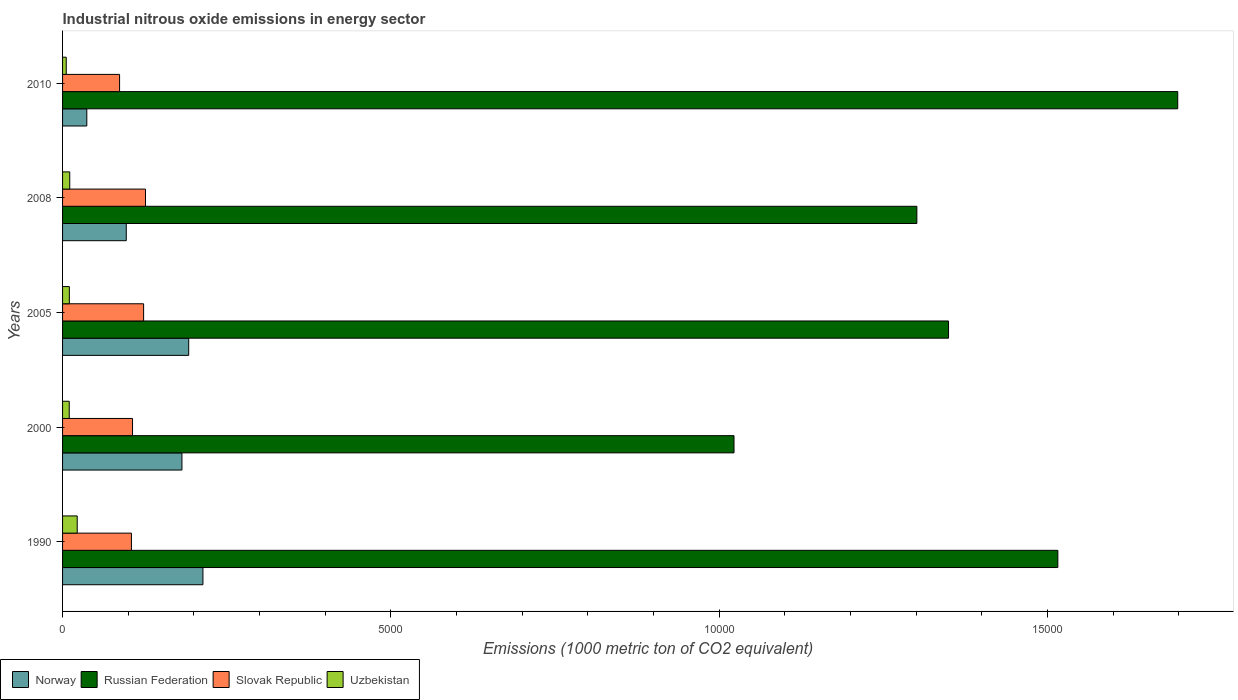How many different coloured bars are there?
Offer a very short reply. 4. How many groups of bars are there?
Provide a succinct answer. 5. Are the number of bars per tick equal to the number of legend labels?
Provide a succinct answer. Yes. Are the number of bars on each tick of the Y-axis equal?
Keep it short and to the point. Yes. What is the amount of industrial nitrous oxide emitted in Slovak Republic in 1990?
Give a very brief answer. 1049. Across all years, what is the maximum amount of industrial nitrous oxide emitted in Russian Federation?
Your answer should be very brief. 1.70e+04. Across all years, what is the minimum amount of industrial nitrous oxide emitted in Slovak Republic?
Your answer should be compact. 868.5. In which year was the amount of industrial nitrous oxide emitted in Uzbekistan maximum?
Your answer should be very brief. 1990. What is the total amount of industrial nitrous oxide emitted in Norway in the graph?
Provide a short and direct response. 7217.1. What is the difference between the amount of industrial nitrous oxide emitted in Norway in 1990 and that in 2010?
Your answer should be very brief. 1768.7. What is the difference between the amount of industrial nitrous oxide emitted in Russian Federation in 1990 and the amount of industrial nitrous oxide emitted in Norway in 2005?
Keep it short and to the point. 1.32e+04. What is the average amount of industrial nitrous oxide emitted in Norway per year?
Give a very brief answer. 1443.42. In the year 2005, what is the difference between the amount of industrial nitrous oxide emitted in Russian Federation and amount of industrial nitrous oxide emitted in Uzbekistan?
Your response must be concise. 1.34e+04. In how many years, is the amount of industrial nitrous oxide emitted in Russian Federation greater than 1000 1000 metric ton?
Offer a terse response. 5. What is the ratio of the amount of industrial nitrous oxide emitted in Uzbekistan in 2000 to that in 2008?
Offer a very short reply. 0.93. Is the amount of industrial nitrous oxide emitted in Norway in 1990 less than that in 2008?
Give a very brief answer. No. Is the difference between the amount of industrial nitrous oxide emitted in Russian Federation in 1990 and 2000 greater than the difference between the amount of industrial nitrous oxide emitted in Uzbekistan in 1990 and 2000?
Ensure brevity in your answer.  Yes. What is the difference between the highest and the second highest amount of industrial nitrous oxide emitted in Norway?
Offer a very short reply. 216.8. What is the difference between the highest and the lowest amount of industrial nitrous oxide emitted in Russian Federation?
Make the answer very short. 6758.6. In how many years, is the amount of industrial nitrous oxide emitted in Norway greater than the average amount of industrial nitrous oxide emitted in Norway taken over all years?
Keep it short and to the point. 3. What does the 4th bar from the bottom in 2008 represents?
Your response must be concise. Uzbekistan. How many bars are there?
Your answer should be compact. 20. What is the difference between two consecutive major ticks on the X-axis?
Keep it short and to the point. 5000. Are the values on the major ticks of X-axis written in scientific E-notation?
Your answer should be compact. No. Does the graph contain grids?
Your answer should be very brief. No. What is the title of the graph?
Give a very brief answer. Industrial nitrous oxide emissions in energy sector. What is the label or title of the X-axis?
Provide a succinct answer. Emissions (1000 metric ton of CO2 equivalent). What is the label or title of the Y-axis?
Offer a terse response. Years. What is the Emissions (1000 metric ton of CO2 equivalent) of Norway in 1990?
Provide a short and direct response. 2138. What is the Emissions (1000 metric ton of CO2 equivalent) of Russian Federation in 1990?
Keep it short and to the point. 1.52e+04. What is the Emissions (1000 metric ton of CO2 equivalent) of Slovak Republic in 1990?
Your answer should be very brief. 1049. What is the Emissions (1000 metric ton of CO2 equivalent) of Uzbekistan in 1990?
Your answer should be compact. 223.2. What is the Emissions (1000 metric ton of CO2 equivalent) of Norway in 2000?
Give a very brief answer. 1818.2. What is the Emissions (1000 metric ton of CO2 equivalent) of Russian Federation in 2000?
Your response must be concise. 1.02e+04. What is the Emissions (1000 metric ton of CO2 equivalent) of Slovak Republic in 2000?
Make the answer very short. 1065.7. What is the Emissions (1000 metric ton of CO2 equivalent) of Uzbekistan in 2000?
Ensure brevity in your answer.  101.6. What is the Emissions (1000 metric ton of CO2 equivalent) in Norway in 2005?
Provide a succinct answer. 1921.2. What is the Emissions (1000 metric ton of CO2 equivalent) of Russian Federation in 2005?
Provide a succinct answer. 1.35e+04. What is the Emissions (1000 metric ton of CO2 equivalent) in Slovak Republic in 2005?
Offer a very short reply. 1234.3. What is the Emissions (1000 metric ton of CO2 equivalent) in Uzbekistan in 2005?
Your answer should be very brief. 103.2. What is the Emissions (1000 metric ton of CO2 equivalent) of Norway in 2008?
Ensure brevity in your answer.  970.4. What is the Emissions (1000 metric ton of CO2 equivalent) in Russian Federation in 2008?
Provide a succinct answer. 1.30e+04. What is the Emissions (1000 metric ton of CO2 equivalent) of Slovak Republic in 2008?
Provide a succinct answer. 1263.1. What is the Emissions (1000 metric ton of CO2 equivalent) in Uzbekistan in 2008?
Offer a terse response. 109.4. What is the Emissions (1000 metric ton of CO2 equivalent) of Norway in 2010?
Your answer should be compact. 369.3. What is the Emissions (1000 metric ton of CO2 equivalent) of Russian Federation in 2010?
Make the answer very short. 1.70e+04. What is the Emissions (1000 metric ton of CO2 equivalent) of Slovak Republic in 2010?
Your response must be concise. 868.5. What is the Emissions (1000 metric ton of CO2 equivalent) of Uzbekistan in 2010?
Provide a short and direct response. 56.1. Across all years, what is the maximum Emissions (1000 metric ton of CO2 equivalent) of Norway?
Make the answer very short. 2138. Across all years, what is the maximum Emissions (1000 metric ton of CO2 equivalent) in Russian Federation?
Give a very brief answer. 1.70e+04. Across all years, what is the maximum Emissions (1000 metric ton of CO2 equivalent) in Slovak Republic?
Provide a succinct answer. 1263.1. Across all years, what is the maximum Emissions (1000 metric ton of CO2 equivalent) of Uzbekistan?
Your response must be concise. 223.2. Across all years, what is the minimum Emissions (1000 metric ton of CO2 equivalent) of Norway?
Make the answer very short. 369.3. Across all years, what is the minimum Emissions (1000 metric ton of CO2 equivalent) in Russian Federation?
Make the answer very short. 1.02e+04. Across all years, what is the minimum Emissions (1000 metric ton of CO2 equivalent) of Slovak Republic?
Your answer should be compact. 868.5. Across all years, what is the minimum Emissions (1000 metric ton of CO2 equivalent) in Uzbekistan?
Provide a succinct answer. 56.1. What is the total Emissions (1000 metric ton of CO2 equivalent) of Norway in the graph?
Ensure brevity in your answer.  7217.1. What is the total Emissions (1000 metric ton of CO2 equivalent) of Russian Federation in the graph?
Keep it short and to the point. 6.89e+04. What is the total Emissions (1000 metric ton of CO2 equivalent) in Slovak Republic in the graph?
Make the answer very short. 5480.6. What is the total Emissions (1000 metric ton of CO2 equivalent) in Uzbekistan in the graph?
Provide a succinct answer. 593.5. What is the difference between the Emissions (1000 metric ton of CO2 equivalent) in Norway in 1990 and that in 2000?
Provide a succinct answer. 319.8. What is the difference between the Emissions (1000 metric ton of CO2 equivalent) in Russian Federation in 1990 and that in 2000?
Ensure brevity in your answer.  4932.4. What is the difference between the Emissions (1000 metric ton of CO2 equivalent) of Slovak Republic in 1990 and that in 2000?
Keep it short and to the point. -16.7. What is the difference between the Emissions (1000 metric ton of CO2 equivalent) in Uzbekistan in 1990 and that in 2000?
Give a very brief answer. 121.6. What is the difference between the Emissions (1000 metric ton of CO2 equivalent) in Norway in 1990 and that in 2005?
Ensure brevity in your answer.  216.8. What is the difference between the Emissions (1000 metric ton of CO2 equivalent) in Russian Federation in 1990 and that in 2005?
Your answer should be very brief. 1664.9. What is the difference between the Emissions (1000 metric ton of CO2 equivalent) of Slovak Republic in 1990 and that in 2005?
Keep it short and to the point. -185.3. What is the difference between the Emissions (1000 metric ton of CO2 equivalent) of Uzbekistan in 1990 and that in 2005?
Offer a terse response. 120. What is the difference between the Emissions (1000 metric ton of CO2 equivalent) in Norway in 1990 and that in 2008?
Ensure brevity in your answer.  1167.6. What is the difference between the Emissions (1000 metric ton of CO2 equivalent) of Russian Federation in 1990 and that in 2008?
Ensure brevity in your answer.  2147.2. What is the difference between the Emissions (1000 metric ton of CO2 equivalent) of Slovak Republic in 1990 and that in 2008?
Your answer should be compact. -214.1. What is the difference between the Emissions (1000 metric ton of CO2 equivalent) of Uzbekistan in 1990 and that in 2008?
Make the answer very short. 113.8. What is the difference between the Emissions (1000 metric ton of CO2 equivalent) in Norway in 1990 and that in 2010?
Keep it short and to the point. 1768.7. What is the difference between the Emissions (1000 metric ton of CO2 equivalent) of Russian Federation in 1990 and that in 2010?
Your answer should be compact. -1826.2. What is the difference between the Emissions (1000 metric ton of CO2 equivalent) in Slovak Republic in 1990 and that in 2010?
Ensure brevity in your answer.  180.5. What is the difference between the Emissions (1000 metric ton of CO2 equivalent) in Uzbekistan in 1990 and that in 2010?
Your answer should be very brief. 167.1. What is the difference between the Emissions (1000 metric ton of CO2 equivalent) in Norway in 2000 and that in 2005?
Your response must be concise. -103. What is the difference between the Emissions (1000 metric ton of CO2 equivalent) in Russian Federation in 2000 and that in 2005?
Offer a very short reply. -3267.5. What is the difference between the Emissions (1000 metric ton of CO2 equivalent) in Slovak Republic in 2000 and that in 2005?
Make the answer very short. -168.6. What is the difference between the Emissions (1000 metric ton of CO2 equivalent) in Uzbekistan in 2000 and that in 2005?
Provide a short and direct response. -1.6. What is the difference between the Emissions (1000 metric ton of CO2 equivalent) in Norway in 2000 and that in 2008?
Your answer should be compact. 847.8. What is the difference between the Emissions (1000 metric ton of CO2 equivalent) of Russian Federation in 2000 and that in 2008?
Ensure brevity in your answer.  -2785.2. What is the difference between the Emissions (1000 metric ton of CO2 equivalent) of Slovak Republic in 2000 and that in 2008?
Make the answer very short. -197.4. What is the difference between the Emissions (1000 metric ton of CO2 equivalent) in Uzbekistan in 2000 and that in 2008?
Keep it short and to the point. -7.8. What is the difference between the Emissions (1000 metric ton of CO2 equivalent) in Norway in 2000 and that in 2010?
Ensure brevity in your answer.  1448.9. What is the difference between the Emissions (1000 metric ton of CO2 equivalent) in Russian Federation in 2000 and that in 2010?
Ensure brevity in your answer.  -6758.6. What is the difference between the Emissions (1000 metric ton of CO2 equivalent) in Slovak Republic in 2000 and that in 2010?
Offer a terse response. 197.2. What is the difference between the Emissions (1000 metric ton of CO2 equivalent) in Uzbekistan in 2000 and that in 2010?
Make the answer very short. 45.5. What is the difference between the Emissions (1000 metric ton of CO2 equivalent) in Norway in 2005 and that in 2008?
Provide a succinct answer. 950.8. What is the difference between the Emissions (1000 metric ton of CO2 equivalent) in Russian Federation in 2005 and that in 2008?
Make the answer very short. 482.3. What is the difference between the Emissions (1000 metric ton of CO2 equivalent) in Slovak Republic in 2005 and that in 2008?
Give a very brief answer. -28.8. What is the difference between the Emissions (1000 metric ton of CO2 equivalent) of Norway in 2005 and that in 2010?
Keep it short and to the point. 1551.9. What is the difference between the Emissions (1000 metric ton of CO2 equivalent) in Russian Federation in 2005 and that in 2010?
Provide a short and direct response. -3491.1. What is the difference between the Emissions (1000 metric ton of CO2 equivalent) in Slovak Republic in 2005 and that in 2010?
Offer a very short reply. 365.8. What is the difference between the Emissions (1000 metric ton of CO2 equivalent) of Uzbekistan in 2005 and that in 2010?
Give a very brief answer. 47.1. What is the difference between the Emissions (1000 metric ton of CO2 equivalent) in Norway in 2008 and that in 2010?
Offer a terse response. 601.1. What is the difference between the Emissions (1000 metric ton of CO2 equivalent) in Russian Federation in 2008 and that in 2010?
Give a very brief answer. -3973.4. What is the difference between the Emissions (1000 metric ton of CO2 equivalent) of Slovak Republic in 2008 and that in 2010?
Your answer should be compact. 394.6. What is the difference between the Emissions (1000 metric ton of CO2 equivalent) of Uzbekistan in 2008 and that in 2010?
Your answer should be very brief. 53.3. What is the difference between the Emissions (1000 metric ton of CO2 equivalent) of Norway in 1990 and the Emissions (1000 metric ton of CO2 equivalent) of Russian Federation in 2000?
Provide a short and direct response. -8089.1. What is the difference between the Emissions (1000 metric ton of CO2 equivalent) in Norway in 1990 and the Emissions (1000 metric ton of CO2 equivalent) in Slovak Republic in 2000?
Give a very brief answer. 1072.3. What is the difference between the Emissions (1000 metric ton of CO2 equivalent) in Norway in 1990 and the Emissions (1000 metric ton of CO2 equivalent) in Uzbekistan in 2000?
Give a very brief answer. 2036.4. What is the difference between the Emissions (1000 metric ton of CO2 equivalent) of Russian Federation in 1990 and the Emissions (1000 metric ton of CO2 equivalent) of Slovak Republic in 2000?
Your response must be concise. 1.41e+04. What is the difference between the Emissions (1000 metric ton of CO2 equivalent) of Russian Federation in 1990 and the Emissions (1000 metric ton of CO2 equivalent) of Uzbekistan in 2000?
Your response must be concise. 1.51e+04. What is the difference between the Emissions (1000 metric ton of CO2 equivalent) of Slovak Republic in 1990 and the Emissions (1000 metric ton of CO2 equivalent) of Uzbekistan in 2000?
Provide a short and direct response. 947.4. What is the difference between the Emissions (1000 metric ton of CO2 equivalent) in Norway in 1990 and the Emissions (1000 metric ton of CO2 equivalent) in Russian Federation in 2005?
Give a very brief answer. -1.14e+04. What is the difference between the Emissions (1000 metric ton of CO2 equivalent) in Norway in 1990 and the Emissions (1000 metric ton of CO2 equivalent) in Slovak Republic in 2005?
Offer a very short reply. 903.7. What is the difference between the Emissions (1000 metric ton of CO2 equivalent) in Norway in 1990 and the Emissions (1000 metric ton of CO2 equivalent) in Uzbekistan in 2005?
Give a very brief answer. 2034.8. What is the difference between the Emissions (1000 metric ton of CO2 equivalent) in Russian Federation in 1990 and the Emissions (1000 metric ton of CO2 equivalent) in Slovak Republic in 2005?
Your answer should be very brief. 1.39e+04. What is the difference between the Emissions (1000 metric ton of CO2 equivalent) in Russian Federation in 1990 and the Emissions (1000 metric ton of CO2 equivalent) in Uzbekistan in 2005?
Ensure brevity in your answer.  1.51e+04. What is the difference between the Emissions (1000 metric ton of CO2 equivalent) in Slovak Republic in 1990 and the Emissions (1000 metric ton of CO2 equivalent) in Uzbekistan in 2005?
Provide a short and direct response. 945.8. What is the difference between the Emissions (1000 metric ton of CO2 equivalent) of Norway in 1990 and the Emissions (1000 metric ton of CO2 equivalent) of Russian Federation in 2008?
Offer a terse response. -1.09e+04. What is the difference between the Emissions (1000 metric ton of CO2 equivalent) in Norway in 1990 and the Emissions (1000 metric ton of CO2 equivalent) in Slovak Republic in 2008?
Your answer should be compact. 874.9. What is the difference between the Emissions (1000 metric ton of CO2 equivalent) of Norway in 1990 and the Emissions (1000 metric ton of CO2 equivalent) of Uzbekistan in 2008?
Your answer should be compact. 2028.6. What is the difference between the Emissions (1000 metric ton of CO2 equivalent) of Russian Federation in 1990 and the Emissions (1000 metric ton of CO2 equivalent) of Slovak Republic in 2008?
Provide a succinct answer. 1.39e+04. What is the difference between the Emissions (1000 metric ton of CO2 equivalent) of Russian Federation in 1990 and the Emissions (1000 metric ton of CO2 equivalent) of Uzbekistan in 2008?
Ensure brevity in your answer.  1.51e+04. What is the difference between the Emissions (1000 metric ton of CO2 equivalent) in Slovak Republic in 1990 and the Emissions (1000 metric ton of CO2 equivalent) in Uzbekistan in 2008?
Your answer should be compact. 939.6. What is the difference between the Emissions (1000 metric ton of CO2 equivalent) in Norway in 1990 and the Emissions (1000 metric ton of CO2 equivalent) in Russian Federation in 2010?
Offer a terse response. -1.48e+04. What is the difference between the Emissions (1000 metric ton of CO2 equivalent) of Norway in 1990 and the Emissions (1000 metric ton of CO2 equivalent) of Slovak Republic in 2010?
Make the answer very short. 1269.5. What is the difference between the Emissions (1000 metric ton of CO2 equivalent) in Norway in 1990 and the Emissions (1000 metric ton of CO2 equivalent) in Uzbekistan in 2010?
Provide a succinct answer. 2081.9. What is the difference between the Emissions (1000 metric ton of CO2 equivalent) of Russian Federation in 1990 and the Emissions (1000 metric ton of CO2 equivalent) of Slovak Republic in 2010?
Your answer should be compact. 1.43e+04. What is the difference between the Emissions (1000 metric ton of CO2 equivalent) in Russian Federation in 1990 and the Emissions (1000 metric ton of CO2 equivalent) in Uzbekistan in 2010?
Offer a very short reply. 1.51e+04. What is the difference between the Emissions (1000 metric ton of CO2 equivalent) of Slovak Republic in 1990 and the Emissions (1000 metric ton of CO2 equivalent) of Uzbekistan in 2010?
Your response must be concise. 992.9. What is the difference between the Emissions (1000 metric ton of CO2 equivalent) in Norway in 2000 and the Emissions (1000 metric ton of CO2 equivalent) in Russian Federation in 2005?
Ensure brevity in your answer.  -1.17e+04. What is the difference between the Emissions (1000 metric ton of CO2 equivalent) in Norway in 2000 and the Emissions (1000 metric ton of CO2 equivalent) in Slovak Republic in 2005?
Make the answer very short. 583.9. What is the difference between the Emissions (1000 metric ton of CO2 equivalent) in Norway in 2000 and the Emissions (1000 metric ton of CO2 equivalent) in Uzbekistan in 2005?
Offer a very short reply. 1715. What is the difference between the Emissions (1000 metric ton of CO2 equivalent) of Russian Federation in 2000 and the Emissions (1000 metric ton of CO2 equivalent) of Slovak Republic in 2005?
Ensure brevity in your answer.  8992.8. What is the difference between the Emissions (1000 metric ton of CO2 equivalent) in Russian Federation in 2000 and the Emissions (1000 metric ton of CO2 equivalent) in Uzbekistan in 2005?
Ensure brevity in your answer.  1.01e+04. What is the difference between the Emissions (1000 metric ton of CO2 equivalent) in Slovak Republic in 2000 and the Emissions (1000 metric ton of CO2 equivalent) in Uzbekistan in 2005?
Keep it short and to the point. 962.5. What is the difference between the Emissions (1000 metric ton of CO2 equivalent) of Norway in 2000 and the Emissions (1000 metric ton of CO2 equivalent) of Russian Federation in 2008?
Give a very brief answer. -1.12e+04. What is the difference between the Emissions (1000 metric ton of CO2 equivalent) of Norway in 2000 and the Emissions (1000 metric ton of CO2 equivalent) of Slovak Republic in 2008?
Make the answer very short. 555.1. What is the difference between the Emissions (1000 metric ton of CO2 equivalent) of Norway in 2000 and the Emissions (1000 metric ton of CO2 equivalent) of Uzbekistan in 2008?
Offer a very short reply. 1708.8. What is the difference between the Emissions (1000 metric ton of CO2 equivalent) of Russian Federation in 2000 and the Emissions (1000 metric ton of CO2 equivalent) of Slovak Republic in 2008?
Offer a very short reply. 8964. What is the difference between the Emissions (1000 metric ton of CO2 equivalent) of Russian Federation in 2000 and the Emissions (1000 metric ton of CO2 equivalent) of Uzbekistan in 2008?
Provide a short and direct response. 1.01e+04. What is the difference between the Emissions (1000 metric ton of CO2 equivalent) of Slovak Republic in 2000 and the Emissions (1000 metric ton of CO2 equivalent) of Uzbekistan in 2008?
Your answer should be very brief. 956.3. What is the difference between the Emissions (1000 metric ton of CO2 equivalent) of Norway in 2000 and the Emissions (1000 metric ton of CO2 equivalent) of Russian Federation in 2010?
Keep it short and to the point. -1.52e+04. What is the difference between the Emissions (1000 metric ton of CO2 equivalent) of Norway in 2000 and the Emissions (1000 metric ton of CO2 equivalent) of Slovak Republic in 2010?
Offer a very short reply. 949.7. What is the difference between the Emissions (1000 metric ton of CO2 equivalent) in Norway in 2000 and the Emissions (1000 metric ton of CO2 equivalent) in Uzbekistan in 2010?
Keep it short and to the point. 1762.1. What is the difference between the Emissions (1000 metric ton of CO2 equivalent) in Russian Federation in 2000 and the Emissions (1000 metric ton of CO2 equivalent) in Slovak Republic in 2010?
Your answer should be very brief. 9358.6. What is the difference between the Emissions (1000 metric ton of CO2 equivalent) in Russian Federation in 2000 and the Emissions (1000 metric ton of CO2 equivalent) in Uzbekistan in 2010?
Offer a terse response. 1.02e+04. What is the difference between the Emissions (1000 metric ton of CO2 equivalent) in Slovak Republic in 2000 and the Emissions (1000 metric ton of CO2 equivalent) in Uzbekistan in 2010?
Give a very brief answer. 1009.6. What is the difference between the Emissions (1000 metric ton of CO2 equivalent) in Norway in 2005 and the Emissions (1000 metric ton of CO2 equivalent) in Russian Federation in 2008?
Your answer should be very brief. -1.11e+04. What is the difference between the Emissions (1000 metric ton of CO2 equivalent) of Norway in 2005 and the Emissions (1000 metric ton of CO2 equivalent) of Slovak Republic in 2008?
Provide a succinct answer. 658.1. What is the difference between the Emissions (1000 metric ton of CO2 equivalent) of Norway in 2005 and the Emissions (1000 metric ton of CO2 equivalent) of Uzbekistan in 2008?
Your answer should be very brief. 1811.8. What is the difference between the Emissions (1000 metric ton of CO2 equivalent) of Russian Federation in 2005 and the Emissions (1000 metric ton of CO2 equivalent) of Slovak Republic in 2008?
Keep it short and to the point. 1.22e+04. What is the difference between the Emissions (1000 metric ton of CO2 equivalent) in Russian Federation in 2005 and the Emissions (1000 metric ton of CO2 equivalent) in Uzbekistan in 2008?
Your answer should be very brief. 1.34e+04. What is the difference between the Emissions (1000 metric ton of CO2 equivalent) of Slovak Republic in 2005 and the Emissions (1000 metric ton of CO2 equivalent) of Uzbekistan in 2008?
Make the answer very short. 1124.9. What is the difference between the Emissions (1000 metric ton of CO2 equivalent) in Norway in 2005 and the Emissions (1000 metric ton of CO2 equivalent) in Russian Federation in 2010?
Your answer should be very brief. -1.51e+04. What is the difference between the Emissions (1000 metric ton of CO2 equivalent) of Norway in 2005 and the Emissions (1000 metric ton of CO2 equivalent) of Slovak Republic in 2010?
Offer a very short reply. 1052.7. What is the difference between the Emissions (1000 metric ton of CO2 equivalent) in Norway in 2005 and the Emissions (1000 metric ton of CO2 equivalent) in Uzbekistan in 2010?
Provide a succinct answer. 1865.1. What is the difference between the Emissions (1000 metric ton of CO2 equivalent) of Russian Federation in 2005 and the Emissions (1000 metric ton of CO2 equivalent) of Slovak Republic in 2010?
Ensure brevity in your answer.  1.26e+04. What is the difference between the Emissions (1000 metric ton of CO2 equivalent) of Russian Federation in 2005 and the Emissions (1000 metric ton of CO2 equivalent) of Uzbekistan in 2010?
Offer a very short reply. 1.34e+04. What is the difference between the Emissions (1000 metric ton of CO2 equivalent) of Slovak Republic in 2005 and the Emissions (1000 metric ton of CO2 equivalent) of Uzbekistan in 2010?
Keep it short and to the point. 1178.2. What is the difference between the Emissions (1000 metric ton of CO2 equivalent) of Norway in 2008 and the Emissions (1000 metric ton of CO2 equivalent) of Russian Federation in 2010?
Offer a very short reply. -1.60e+04. What is the difference between the Emissions (1000 metric ton of CO2 equivalent) of Norway in 2008 and the Emissions (1000 metric ton of CO2 equivalent) of Slovak Republic in 2010?
Give a very brief answer. 101.9. What is the difference between the Emissions (1000 metric ton of CO2 equivalent) of Norway in 2008 and the Emissions (1000 metric ton of CO2 equivalent) of Uzbekistan in 2010?
Give a very brief answer. 914.3. What is the difference between the Emissions (1000 metric ton of CO2 equivalent) in Russian Federation in 2008 and the Emissions (1000 metric ton of CO2 equivalent) in Slovak Republic in 2010?
Ensure brevity in your answer.  1.21e+04. What is the difference between the Emissions (1000 metric ton of CO2 equivalent) of Russian Federation in 2008 and the Emissions (1000 metric ton of CO2 equivalent) of Uzbekistan in 2010?
Ensure brevity in your answer.  1.30e+04. What is the difference between the Emissions (1000 metric ton of CO2 equivalent) of Slovak Republic in 2008 and the Emissions (1000 metric ton of CO2 equivalent) of Uzbekistan in 2010?
Offer a very short reply. 1207. What is the average Emissions (1000 metric ton of CO2 equivalent) in Norway per year?
Offer a very short reply. 1443.42. What is the average Emissions (1000 metric ton of CO2 equivalent) in Russian Federation per year?
Your answer should be compact. 1.38e+04. What is the average Emissions (1000 metric ton of CO2 equivalent) of Slovak Republic per year?
Provide a succinct answer. 1096.12. What is the average Emissions (1000 metric ton of CO2 equivalent) in Uzbekistan per year?
Provide a succinct answer. 118.7. In the year 1990, what is the difference between the Emissions (1000 metric ton of CO2 equivalent) of Norway and Emissions (1000 metric ton of CO2 equivalent) of Russian Federation?
Make the answer very short. -1.30e+04. In the year 1990, what is the difference between the Emissions (1000 metric ton of CO2 equivalent) in Norway and Emissions (1000 metric ton of CO2 equivalent) in Slovak Republic?
Your answer should be very brief. 1089. In the year 1990, what is the difference between the Emissions (1000 metric ton of CO2 equivalent) of Norway and Emissions (1000 metric ton of CO2 equivalent) of Uzbekistan?
Your answer should be compact. 1914.8. In the year 1990, what is the difference between the Emissions (1000 metric ton of CO2 equivalent) in Russian Federation and Emissions (1000 metric ton of CO2 equivalent) in Slovak Republic?
Your answer should be very brief. 1.41e+04. In the year 1990, what is the difference between the Emissions (1000 metric ton of CO2 equivalent) of Russian Federation and Emissions (1000 metric ton of CO2 equivalent) of Uzbekistan?
Provide a succinct answer. 1.49e+04. In the year 1990, what is the difference between the Emissions (1000 metric ton of CO2 equivalent) in Slovak Republic and Emissions (1000 metric ton of CO2 equivalent) in Uzbekistan?
Provide a short and direct response. 825.8. In the year 2000, what is the difference between the Emissions (1000 metric ton of CO2 equivalent) of Norway and Emissions (1000 metric ton of CO2 equivalent) of Russian Federation?
Offer a very short reply. -8408.9. In the year 2000, what is the difference between the Emissions (1000 metric ton of CO2 equivalent) in Norway and Emissions (1000 metric ton of CO2 equivalent) in Slovak Republic?
Your answer should be compact. 752.5. In the year 2000, what is the difference between the Emissions (1000 metric ton of CO2 equivalent) of Norway and Emissions (1000 metric ton of CO2 equivalent) of Uzbekistan?
Ensure brevity in your answer.  1716.6. In the year 2000, what is the difference between the Emissions (1000 metric ton of CO2 equivalent) in Russian Federation and Emissions (1000 metric ton of CO2 equivalent) in Slovak Republic?
Keep it short and to the point. 9161.4. In the year 2000, what is the difference between the Emissions (1000 metric ton of CO2 equivalent) of Russian Federation and Emissions (1000 metric ton of CO2 equivalent) of Uzbekistan?
Your answer should be compact. 1.01e+04. In the year 2000, what is the difference between the Emissions (1000 metric ton of CO2 equivalent) of Slovak Republic and Emissions (1000 metric ton of CO2 equivalent) of Uzbekistan?
Offer a terse response. 964.1. In the year 2005, what is the difference between the Emissions (1000 metric ton of CO2 equivalent) of Norway and Emissions (1000 metric ton of CO2 equivalent) of Russian Federation?
Give a very brief answer. -1.16e+04. In the year 2005, what is the difference between the Emissions (1000 metric ton of CO2 equivalent) in Norway and Emissions (1000 metric ton of CO2 equivalent) in Slovak Republic?
Provide a short and direct response. 686.9. In the year 2005, what is the difference between the Emissions (1000 metric ton of CO2 equivalent) in Norway and Emissions (1000 metric ton of CO2 equivalent) in Uzbekistan?
Provide a succinct answer. 1818. In the year 2005, what is the difference between the Emissions (1000 metric ton of CO2 equivalent) in Russian Federation and Emissions (1000 metric ton of CO2 equivalent) in Slovak Republic?
Your answer should be very brief. 1.23e+04. In the year 2005, what is the difference between the Emissions (1000 metric ton of CO2 equivalent) in Russian Federation and Emissions (1000 metric ton of CO2 equivalent) in Uzbekistan?
Your answer should be compact. 1.34e+04. In the year 2005, what is the difference between the Emissions (1000 metric ton of CO2 equivalent) in Slovak Republic and Emissions (1000 metric ton of CO2 equivalent) in Uzbekistan?
Offer a terse response. 1131.1. In the year 2008, what is the difference between the Emissions (1000 metric ton of CO2 equivalent) of Norway and Emissions (1000 metric ton of CO2 equivalent) of Russian Federation?
Your answer should be compact. -1.20e+04. In the year 2008, what is the difference between the Emissions (1000 metric ton of CO2 equivalent) of Norway and Emissions (1000 metric ton of CO2 equivalent) of Slovak Republic?
Your response must be concise. -292.7. In the year 2008, what is the difference between the Emissions (1000 metric ton of CO2 equivalent) of Norway and Emissions (1000 metric ton of CO2 equivalent) of Uzbekistan?
Provide a succinct answer. 861. In the year 2008, what is the difference between the Emissions (1000 metric ton of CO2 equivalent) of Russian Federation and Emissions (1000 metric ton of CO2 equivalent) of Slovak Republic?
Ensure brevity in your answer.  1.17e+04. In the year 2008, what is the difference between the Emissions (1000 metric ton of CO2 equivalent) in Russian Federation and Emissions (1000 metric ton of CO2 equivalent) in Uzbekistan?
Make the answer very short. 1.29e+04. In the year 2008, what is the difference between the Emissions (1000 metric ton of CO2 equivalent) of Slovak Republic and Emissions (1000 metric ton of CO2 equivalent) of Uzbekistan?
Your answer should be compact. 1153.7. In the year 2010, what is the difference between the Emissions (1000 metric ton of CO2 equivalent) of Norway and Emissions (1000 metric ton of CO2 equivalent) of Russian Federation?
Your answer should be compact. -1.66e+04. In the year 2010, what is the difference between the Emissions (1000 metric ton of CO2 equivalent) in Norway and Emissions (1000 metric ton of CO2 equivalent) in Slovak Republic?
Offer a terse response. -499.2. In the year 2010, what is the difference between the Emissions (1000 metric ton of CO2 equivalent) of Norway and Emissions (1000 metric ton of CO2 equivalent) of Uzbekistan?
Offer a very short reply. 313.2. In the year 2010, what is the difference between the Emissions (1000 metric ton of CO2 equivalent) of Russian Federation and Emissions (1000 metric ton of CO2 equivalent) of Slovak Republic?
Provide a succinct answer. 1.61e+04. In the year 2010, what is the difference between the Emissions (1000 metric ton of CO2 equivalent) of Russian Federation and Emissions (1000 metric ton of CO2 equivalent) of Uzbekistan?
Your answer should be compact. 1.69e+04. In the year 2010, what is the difference between the Emissions (1000 metric ton of CO2 equivalent) of Slovak Republic and Emissions (1000 metric ton of CO2 equivalent) of Uzbekistan?
Provide a succinct answer. 812.4. What is the ratio of the Emissions (1000 metric ton of CO2 equivalent) of Norway in 1990 to that in 2000?
Make the answer very short. 1.18. What is the ratio of the Emissions (1000 metric ton of CO2 equivalent) of Russian Federation in 1990 to that in 2000?
Make the answer very short. 1.48. What is the ratio of the Emissions (1000 metric ton of CO2 equivalent) of Slovak Republic in 1990 to that in 2000?
Keep it short and to the point. 0.98. What is the ratio of the Emissions (1000 metric ton of CO2 equivalent) in Uzbekistan in 1990 to that in 2000?
Keep it short and to the point. 2.2. What is the ratio of the Emissions (1000 metric ton of CO2 equivalent) of Norway in 1990 to that in 2005?
Offer a very short reply. 1.11. What is the ratio of the Emissions (1000 metric ton of CO2 equivalent) of Russian Federation in 1990 to that in 2005?
Your answer should be very brief. 1.12. What is the ratio of the Emissions (1000 metric ton of CO2 equivalent) in Slovak Republic in 1990 to that in 2005?
Your response must be concise. 0.85. What is the ratio of the Emissions (1000 metric ton of CO2 equivalent) in Uzbekistan in 1990 to that in 2005?
Your answer should be very brief. 2.16. What is the ratio of the Emissions (1000 metric ton of CO2 equivalent) of Norway in 1990 to that in 2008?
Keep it short and to the point. 2.2. What is the ratio of the Emissions (1000 metric ton of CO2 equivalent) of Russian Federation in 1990 to that in 2008?
Provide a short and direct response. 1.17. What is the ratio of the Emissions (1000 metric ton of CO2 equivalent) in Slovak Republic in 1990 to that in 2008?
Your response must be concise. 0.83. What is the ratio of the Emissions (1000 metric ton of CO2 equivalent) in Uzbekistan in 1990 to that in 2008?
Make the answer very short. 2.04. What is the ratio of the Emissions (1000 metric ton of CO2 equivalent) of Norway in 1990 to that in 2010?
Your response must be concise. 5.79. What is the ratio of the Emissions (1000 metric ton of CO2 equivalent) in Russian Federation in 1990 to that in 2010?
Keep it short and to the point. 0.89. What is the ratio of the Emissions (1000 metric ton of CO2 equivalent) of Slovak Republic in 1990 to that in 2010?
Your answer should be very brief. 1.21. What is the ratio of the Emissions (1000 metric ton of CO2 equivalent) of Uzbekistan in 1990 to that in 2010?
Your answer should be very brief. 3.98. What is the ratio of the Emissions (1000 metric ton of CO2 equivalent) of Norway in 2000 to that in 2005?
Ensure brevity in your answer.  0.95. What is the ratio of the Emissions (1000 metric ton of CO2 equivalent) of Russian Federation in 2000 to that in 2005?
Offer a terse response. 0.76. What is the ratio of the Emissions (1000 metric ton of CO2 equivalent) in Slovak Republic in 2000 to that in 2005?
Ensure brevity in your answer.  0.86. What is the ratio of the Emissions (1000 metric ton of CO2 equivalent) of Uzbekistan in 2000 to that in 2005?
Your answer should be compact. 0.98. What is the ratio of the Emissions (1000 metric ton of CO2 equivalent) of Norway in 2000 to that in 2008?
Provide a succinct answer. 1.87. What is the ratio of the Emissions (1000 metric ton of CO2 equivalent) in Russian Federation in 2000 to that in 2008?
Provide a succinct answer. 0.79. What is the ratio of the Emissions (1000 metric ton of CO2 equivalent) of Slovak Republic in 2000 to that in 2008?
Offer a terse response. 0.84. What is the ratio of the Emissions (1000 metric ton of CO2 equivalent) of Uzbekistan in 2000 to that in 2008?
Ensure brevity in your answer.  0.93. What is the ratio of the Emissions (1000 metric ton of CO2 equivalent) in Norway in 2000 to that in 2010?
Your answer should be compact. 4.92. What is the ratio of the Emissions (1000 metric ton of CO2 equivalent) in Russian Federation in 2000 to that in 2010?
Your answer should be very brief. 0.6. What is the ratio of the Emissions (1000 metric ton of CO2 equivalent) in Slovak Republic in 2000 to that in 2010?
Make the answer very short. 1.23. What is the ratio of the Emissions (1000 metric ton of CO2 equivalent) in Uzbekistan in 2000 to that in 2010?
Your response must be concise. 1.81. What is the ratio of the Emissions (1000 metric ton of CO2 equivalent) of Norway in 2005 to that in 2008?
Make the answer very short. 1.98. What is the ratio of the Emissions (1000 metric ton of CO2 equivalent) in Russian Federation in 2005 to that in 2008?
Provide a short and direct response. 1.04. What is the ratio of the Emissions (1000 metric ton of CO2 equivalent) of Slovak Republic in 2005 to that in 2008?
Your response must be concise. 0.98. What is the ratio of the Emissions (1000 metric ton of CO2 equivalent) of Uzbekistan in 2005 to that in 2008?
Ensure brevity in your answer.  0.94. What is the ratio of the Emissions (1000 metric ton of CO2 equivalent) in Norway in 2005 to that in 2010?
Your answer should be very brief. 5.2. What is the ratio of the Emissions (1000 metric ton of CO2 equivalent) in Russian Federation in 2005 to that in 2010?
Your answer should be compact. 0.79. What is the ratio of the Emissions (1000 metric ton of CO2 equivalent) of Slovak Republic in 2005 to that in 2010?
Offer a terse response. 1.42. What is the ratio of the Emissions (1000 metric ton of CO2 equivalent) in Uzbekistan in 2005 to that in 2010?
Offer a terse response. 1.84. What is the ratio of the Emissions (1000 metric ton of CO2 equivalent) of Norway in 2008 to that in 2010?
Offer a very short reply. 2.63. What is the ratio of the Emissions (1000 metric ton of CO2 equivalent) in Russian Federation in 2008 to that in 2010?
Give a very brief answer. 0.77. What is the ratio of the Emissions (1000 metric ton of CO2 equivalent) in Slovak Republic in 2008 to that in 2010?
Provide a succinct answer. 1.45. What is the ratio of the Emissions (1000 metric ton of CO2 equivalent) of Uzbekistan in 2008 to that in 2010?
Your answer should be very brief. 1.95. What is the difference between the highest and the second highest Emissions (1000 metric ton of CO2 equivalent) in Norway?
Provide a succinct answer. 216.8. What is the difference between the highest and the second highest Emissions (1000 metric ton of CO2 equivalent) in Russian Federation?
Ensure brevity in your answer.  1826.2. What is the difference between the highest and the second highest Emissions (1000 metric ton of CO2 equivalent) in Slovak Republic?
Give a very brief answer. 28.8. What is the difference between the highest and the second highest Emissions (1000 metric ton of CO2 equivalent) of Uzbekistan?
Provide a short and direct response. 113.8. What is the difference between the highest and the lowest Emissions (1000 metric ton of CO2 equivalent) in Norway?
Provide a succinct answer. 1768.7. What is the difference between the highest and the lowest Emissions (1000 metric ton of CO2 equivalent) of Russian Federation?
Offer a terse response. 6758.6. What is the difference between the highest and the lowest Emissions (1000 metric ton of CO2 equivalent) in Slovak Republic?
Ensure brevity in your answer.  394.6. What is the difference between the highest and the lowest Emissions (1000 metric ton of CO2 equivalent) in Uzbekistan?
Your answer should be compact. 167.1. 